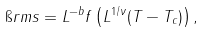Convert formula to latex. <formula><loc_0><loc_0><loc_500><loc_500>\i r m s = L ^ { - b } f \left ( L ^ { 1 / \nu } ( T - T _ { c } ) \right ) ,</formula> 